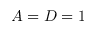Convert formula to latex. <formula><loc_0><loc_0><loc_500><loc_500>A = D = 1</formula> 